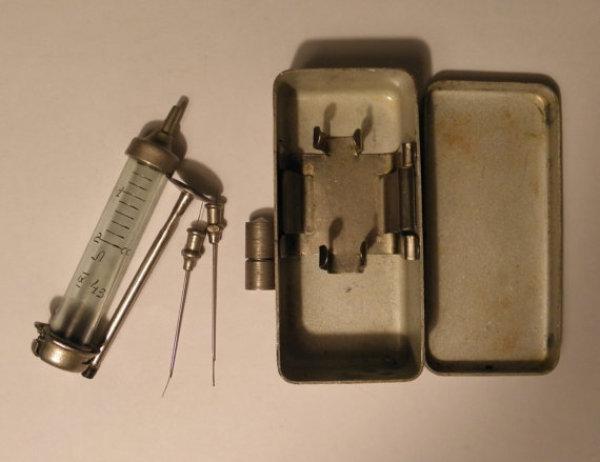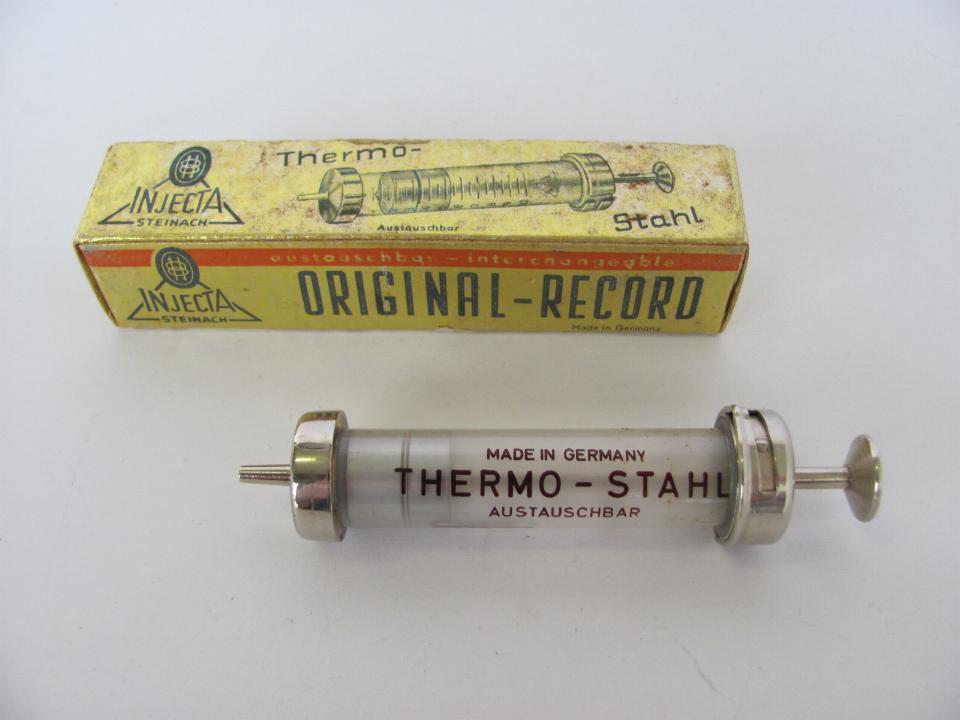The first image is the image on the left, the second image is the image on the right. Assess this claim about the two images: "There are no more than two syringes in total.". Correct or not? Answer yes or no. Yes. The first image is the image on the left, the second image is the image on the right. For the images shown, is this caption "there are at least 3 syringes" true? Answer yes or no. No. 